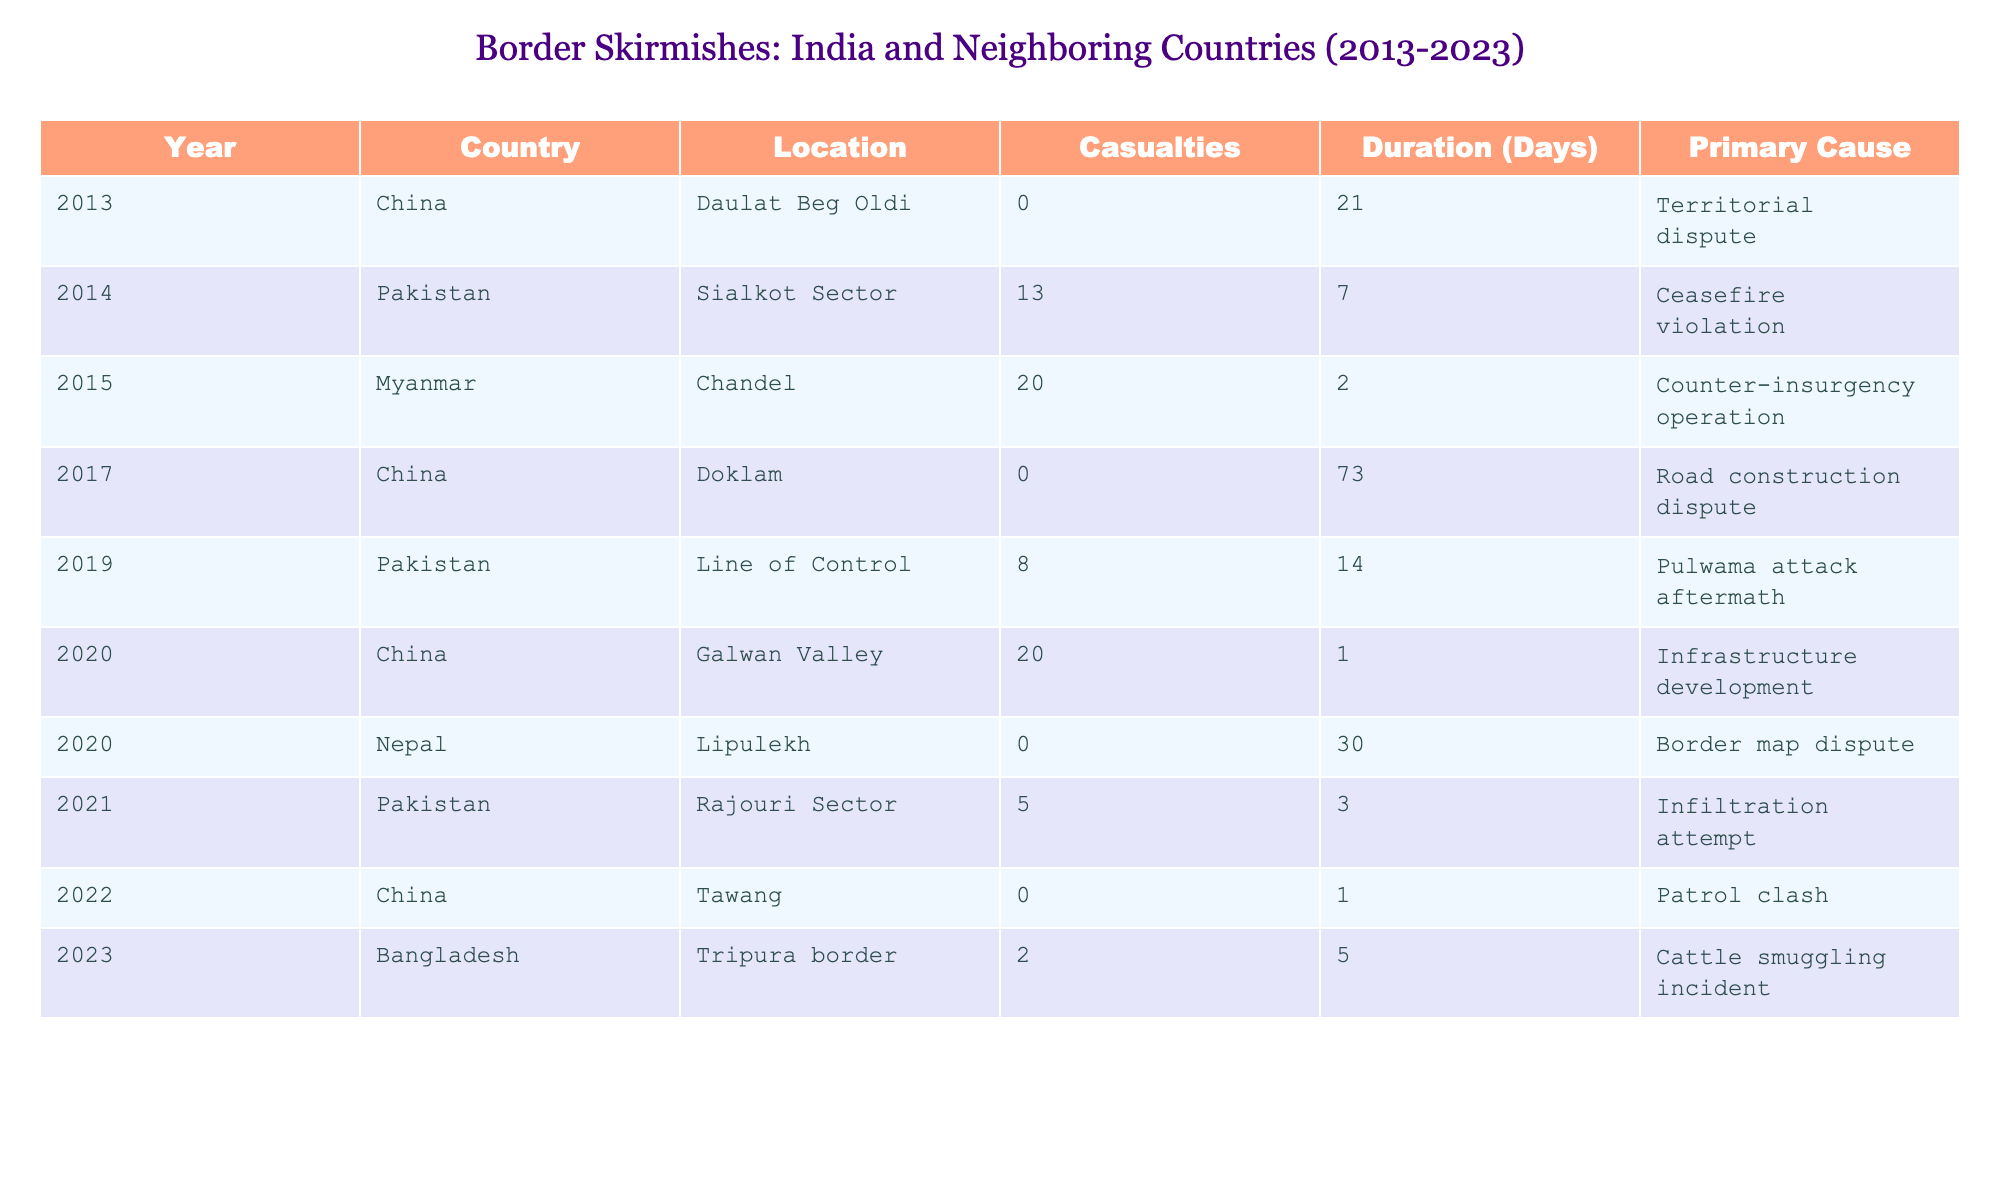What year did the border skirmish occur at the Galwan Valley? The table lists the location of the skirmish at Galwan Valley in the year 2020.
Answer: 2020 How many casualties were reported in the Sialkot Sector skirmish? In the table, it specifies that there were 13 casualties reported in the Sialkot Sector in 2014.
Answer: 13 What is the primary cause of the skirmish that occurred in the Lipulekh region in 2020? The border skirmish at Lipulekh in 2020 is marked as a border map dispute according to the table.
Answer: Border map dispute How many days did the Doklam skirmish last? The duration of the Doklam skirmish in 2017, as stated in the table, was 73 days.
Answer: 73 Which country was involved in the counter-insurgency operation in Chandel? The skirmish in Chandel involved Myanmar, as indicated in the table.
Answer: Myanmar What is the total number of casualties reported across all skirmishes in 2020? The table shows two skirmishes in 2020 — in Galwan Valley (20 casualties) and Lipulekh (0 casualties). Summing them gives 20 + 0 = 20 casualties in total.
Answer: 20 How many days did skirmishes with Pakistan last in 2019? The table states that in 2019, skirmishes at the Line of Control lasted 14 days.
Answer: 14 Did any skirmishes in the provided data have a duration of only 1 day? The table indicates that the Galwan Valley skirmish in 2020 and the Tawang skirmish in 2022 each lasted 1 day. Thus, the answer is yes.
Answer: Yes Which neighboring country had the highest number of casualties listed in the table? By looking at the casualties: 13 (Pakistan - 2014), 20 (Myanmar - 2015), 8 (Pakistan - 2019), and 20 (China - 2020). China has the highest casualties (20).
Answer: China If you sum the casualties from skirmishes with Pakistan, what is the total? The skirmishes with Pakistan had casualties of 13 in 2014, 8 in 2019, and 5 in 2021. Adding these gives 13 + 8 + 5 = 26.
Answer: 26 Which location was involved in a patrol clash in 2022? The table shows that Tawang was the location where a patrol clash occurred in 2022.
Answer: Tawang How many skirmishes resulted in zero casualties? According to the table, the skirmishes in Daulat Beg Oldi (2013), Doklam (2017), and Tawang (2022) all had zero casualties. This totals to three skirmishes.
Answer: 3 What was the primary cause of the skirmish in Tripura in 2023? The table indicates that the Tripura border skirmish in 2023 was due to a cattle smuggling incident.
Answer: Cattle smuggling incident 